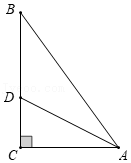What other geometric properties could we explore in this diagram? We could further explore properties such as the Pythagorean Theorem in triangle ABC, the ratios and proportions in the similar triangles ABD and CBD created by the bisector AD, and even delve into trigonometric ratios for deeper insights into angle values and other segment lengths in this configuration. Can you calculate the lengths of AB and BC assuming that angle BAC is 45 degrees? Given AC is 6 units and angle BAC is 45 degrees, triangle ABC is a 45-45-90 triangle. In such triangles, the legs (AB and BC) are equal, and the length of each leg is AC/\ How can mathematical principles in geometry influence practical applications in engineering and architecture? Mathematical principles in geometry, such as understanding right triangles, angle bisectors, and perpendicularity, play a crucial role in engineering and architecture. They help in structuring foundational layouts, ensuring structural integrity through balanced force distribution, and optimizing space in design by utilizing geometric shapes and their properties effectively. These principles facilitate precise calculations necessary for safe and efficient design plans. 